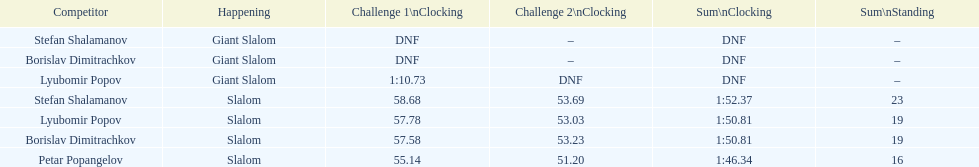Which athlete had a race time above 1:00? Lyubomir Popov. 